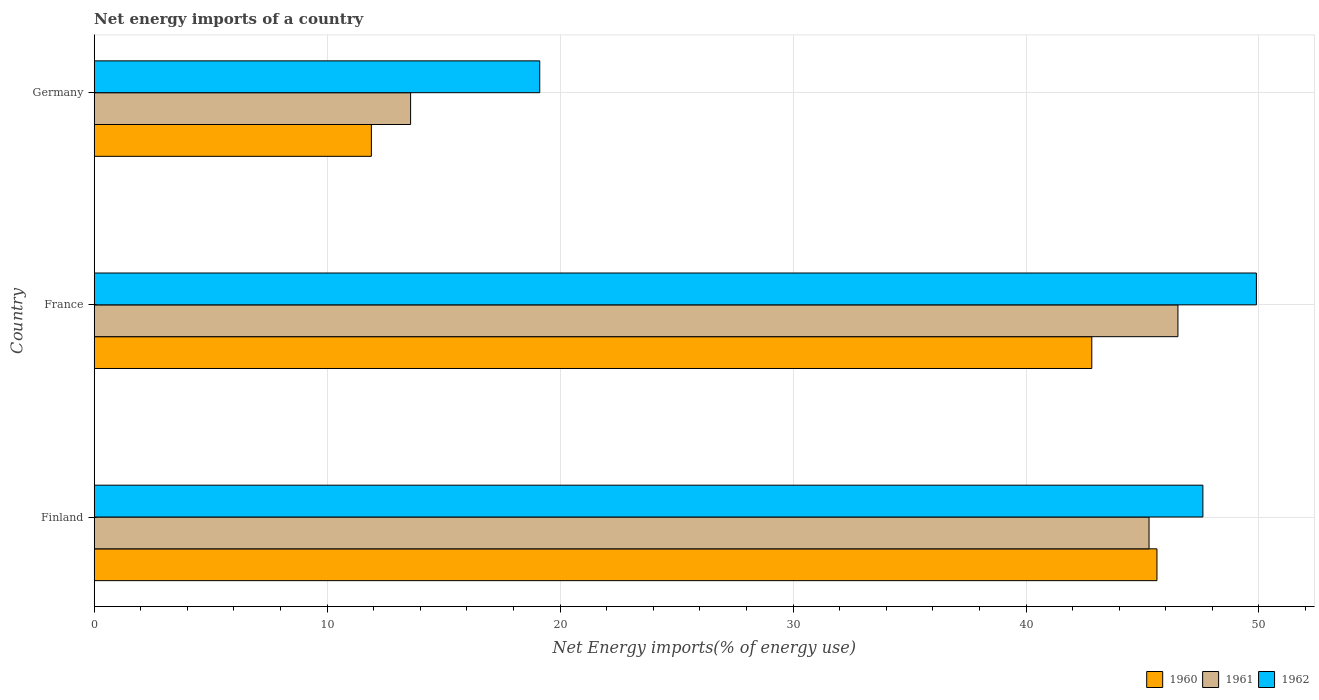How many groups of bars are there?
Make the answer very short. 3. Are the number of bars per tick equal to the number of legend labels?
Provide a short and direct response. Yes. How many bars are there on the 3rd tick from the bottom?
Offer a terse response. 3. In how many cases, is the number of bars for a given country not equal to the number of legend labels?
Provide a succinct answer. 0. What is the net energy imports in 1962 in France?
Provide a succinct answer. 49.89. Across all countries, what is the maximum net energy imports in 1961?
Keep it short and to the point. 46.52. Across all countries, what is the minimum net energy imports in 1960?
Provide a short and direct response. 11.9. In which country was the net energy imports in 1960 maximum?
Ensure brevity in your answer.  Finland. What is the total net energy imports in 1961 in the graph?
Ensure brevity in your answer.  105.38. What is the difference between the net energy imports in 1960 in Finland and that in France?
Your response must be concise. 2.8. What is the difference between the net energy imports in 1961 in Finland and the net energy imports in 1960 in France?
Your response must be concise. 2.46. What is the average net energy imports in 1960 per country?
Provide a succinct answer. 33.45. What is the difference between the net energy imports in 1962 and net energy imports in 1960 in France?
Your answer should be very brief. 7.06. What is the ratio of the net energy imports in 1962 in Finland to that in France?
Make the answer very short. 0.95. Is the net energy imports in 1961 in France less than that in Germany?
Ensure brevity in your answer.  No. Is the difference between the net energy imports in 1962 in France and Germany greater than the difference between the net energy imports in 1960 in France and Germany?
Your answer should be very brief. No. What is the difference between the highest and the second highest net energy imports in 1962?
Provide a succinct answer. 2.3. What is the difference between the highest and the lowest net energy imports in 1962?
Give a very brief answer. 30.76. Is the sum of the net energy imports in 1960 in Finland and France greater than the maximum net energy imports in 1962 across all countries?
Make the answer very short. Yes. What does the 2nd bar from the bottom in Germany represents?
Offer a very short reply. 1961. Is it the case that in every country, the sum of the net energy imports in 1960 and net energy imports in 1961 is greater than the net energy imports in 1962?
Provide a short and direct response. Yes. How many bars are there?
Your answer should be compact. 9. Are all the bars in the graph horizontal?
Provide a succinct answer. Yes. Where does the legend appear in the graph?
Offer a very short reply. Bottom right. How are the legend labels stacked?
Offer a very short reply. Horizontal. What is the title of the graph?
Keep it short and to the point. Net energy imports of a country. What is the label or title of the X-axis?
Offer a very short reply. Net Energy imports(% of energy use). What is the label or title of the Y-axis?
Offer a terse response. Country. What is the Net Energy imports(% of energy use) of 1960 in Finland?
Your answer should be compact. 45.62. What is the Net Energy imports(% of energy use) of 1961 in Finland?
Your answer should be compact. 45.28. What is the Net Energy imports(% of energy use) of 1962 in Finland?
Give a very brief answer. 47.59. What is the Net Energy imports(% of energy use) of 1960 in France?
Make the answer very short. 42.82. What is the Net Energy imports(% of energy use) of 1961 in France?
Provide a short and direct response. 46.52. What is the Net Energy imports(% of energy use) in 1962 in France?
Offer a very short reply. 49.89. What is the Net Energy imports(% of energy use) of 1960 in Germany?
Provide a succinct answer. 11.9. What is the Net Energy imports(% of energy use) in 1961 in Germany?
Give a very brief answer. 13.58. What is the Net Energy imports(% of energy use) of 1962 in Germany?
Provide a short and direct response. 19.13. Across all countries, what is the maximum Net Energy imports(% of energy use) in 1960?
Make the answer very short. 45.62. Across all countries, what is the maximum Net Energy imports(% of energy use) of 1961?
Ensure brevity in your answer.  46.52. Across all countries, what is the maximum Net Energy imports(% of energy use) in 1962?
Provide a succinct answer. 49.89. Across all countries, what is the minimum Net Energy imports(% of energy use) in 1960?
Your answer should be compact. 11.9. Across all countries, what is the minimum Net Energy imports(% of energy use) of 1961?
Give a very brief answer. 13.58. Across all countries, what is the minimum Net Energy imports(% of energy use) of 1962?
Give a very brief answer. 19.13. What is the total Net Energy imports(% of energy use) of 1960 in the graph?
Your answer should be compact. 100.34. What is the total Net Energy imports(% of energy use) of 1961 in the graph?
Your answer should be very brief. 105.38. What is the total Net Energy imports(% of energy use) of 1962 in the graph?
Provide a succinct answer. 116.61. What is the difference between the Net Energy imports(% of energy use) of 1960 in Finland and that in France?
Offer a terse response. 2.8. What is the difference between the Net Energy imports(% of energy use) in 1961 in Finland and that in France?
Make the answer very short. -1.24. What is the difference between the Net Energy imports(% of energy use) of 1962 in Finland and that in France?
Your response must be concise. -2.3. What is the difference between the Net Energy imports(% of energy use) in 1960 in Finland and that in Germany?
Offer a very short reply. 33.72. What is the difference between the Net Energy imports(% of energy use) in 1961 in Finland and that in Germany?
Ensure brevity in your answer.  31.7. What is the difference between the Net Energy imports(% of energy use) in 1962 in Finland and that in Germany?
Your answer should be compact. 28.47. What is the difference between the Net Energy imports(% of energy use) in 1960 in France and that in Germany?
Your response must be concise. 30.93. What is the difference between the Net Energy imports(% of energy use) of 1961 in France and that in Germany?
Give a very brief answer. 32.94. What is the difference between the Net Energy imports(% of energy use) in 1962 in France and that in Germany?
Give a very brief answer. 30.76. What is the difference between the Net Energy imports(% of energy use) in 1960 in Finland and the Net Energy imports(% of energy use) in 1961 in France?
Provide a short and direct response. -0.9. What is the difference between the Net Energy imports(% of energy use) in 1960 in Finland and the Net Energy imports(% of energy use) in 1962 in France?
Your response must be concise. -4.27. What is the difference between the Net Energy imports(% of energy use) in 1961 in Finland and the Net Energy imports(% of energy use) in 1962 in France?
Provide a short and direct response. -4.61. What is the difference between the Net Energy imports(% of energy use) in 1960 in Finland and the Net Energy imports(% of energy use) in 1961 in Germany?
Keep it short and to the point. 32.04. What is the difference between the Net Energy imports(% of energy use) in 1960 in Finland and the Net Energy imports(% of energy use) in 1962 in Germany?
Provide a short and direct response. 26.49. What is the difference between the Net Energy imports(% of energy use) in 1961 in Finland and the Net Energy imports(% of energy use) in 1962 in Germany?
Make the answer very short. 26.15. What is the difference between the Net Energy imports(% of energy use) of 1960 in France and the Net Energy imports(% of energy use) of 1961 in Germany?
Your response must be concise. 29.24. What is the difference between the Net Energy imports(% of energy use) in 1960 in France and the Net Energy imports(% of energy use) in 1962 in Germany?
Your answer should be very brief. 23.7. What is the difference between the Net Energy imports(% of energy use) in 1961 in France and the Net Energy imports(% of energy use) in 1962 in Germany?
Provide a succinct answer. 27.39. What is the average Net Energy imports(% of energy use) of 1960 per country?
Your response must be concise. 33.45. What is the average Net Energy imports(% of energy use) in 1961 per country?
Ensure brevity in your answer.  35.13. What is the average Net Energy imports(% of energy use) of 1962 per country?
Provide a succinct answer. 38.87. What is the difference between the Net Energy imports(% of energy use) in 1960 and Net Energy imports(% of energy use) in 1961 in Finland?
Give a very brief answer. 0.34. What is the difference between the Net Energy imports(% of energy use) in 1960 and Net Energy imports(% of energy use) in 1962 in Finland?
Ensure brevity in your answer.  -1.97. What is the difference between the Net Energy imports(% of energy use) of 1961 and Net Energy imports(% of energy use) of 1962 in Finland?
Your response must be concise. -2.31. What is the difference between the Net Energy imports(% of energy use) of 1960 and Net Energy imports(% of energy use) of 1961 in France?
Ensure brevity in your answer.  -3.7. What is the difference between the Net Energy imports(% of energy use) in 1960 and Net Energy imports(% of energy use) in 1962 in France?
Provide a succinct answer. -7.06. What is the difference between the Net Energy imports(% of energy use) of 1961 and Net Energy imports(% of energy use) of 1962 in France?
Your answer should be very brief. -3.37. What is the difference between the Net Energy imports(% of energy use) of 1960 and Net Energy imports(% of energy use) of 1961 in Germany?
Give a very brief answer. -1.68. What is the difference between the Net Energy imports(% of energy use) of 1960 and Net Energy imports(% of energy use) of 1962 in Germany?
Give a very brief answer. -7.23. What is the difference between the Net Energy imports(% of energy use) of 1961 and Net Energy imports(% of energy use) of 1962 in Germany?
Provide a succinct answer. -5.54. What is the ratio of the Net Energy imports(% of energy use) of 1960 in Finland to that in France?
Your answer should be very brief. 1.07. What is the ratio of the Net Energy imports(% of energy use) of 1961 in Finland to that in France?
Your answer should be compact. 0.97. What is the ratio of the Net Energy imports(% of energy use) in 1962 in Finland to that in France?
Your answer should be compact. 0.95. What is the ratio of the Net Energy imports(% of energy use) of 1960 in Finland to that in Germany?
Offer a terse response. 3.83. What is the ratio of the Net Energy imports(% of energy use) of 1961 in Finland to that in Germany?
Your response must be concise. 3.33. What is the ratio of the Net Energy imports(% of energy use) of 1962 in Finland to that in Germany?
Your response must be concise. 2.49. What is the ratio of the Net Energy imports(% of energy use) in 1960 in France to that in Germany?
Give a very brief answer. 3.6. What is the ratio of the Net Energy imports(% of energy use) in 1961 in France to that in Germany?
Offer a terse response. 3.43. What is the ratio of the Net Energy imports(% of energy use) in 1962 in France to that in Germany?
Ensure brevity in your answer.  2.61. What is the difference between the highest and the second highest Net Energy imports(% of energy use) of 1960?
Ensure brevity in your answer.  2.8. What is the difference between the highest and the second highest Net Energy imports(% of energy use) in 1961?
Provide a succinct answer. 1.24. What is the difference between the highest and the second highest Net Energy imports(% of energy use) of 1962?
Provide a short and direct response. 2.3. What is the difference between the highest and the lowest Net Energy imports(% of energy use) in 1960?
Make the answer very short. 33.72. What is the difference between the highest and the lowest Net Energy imports(% of energy use) in 1961?
Keep it short and to the point. 32.94. What is the difference between the highest and the lowest Net Energy imports(% of energy use) of 1962?
Ensure brevity in your answer.  30.76. 